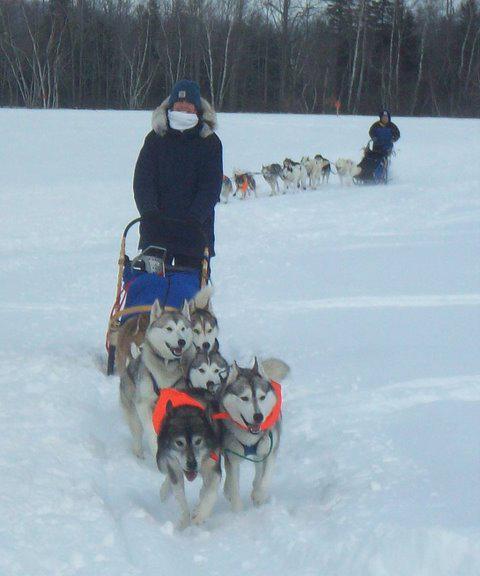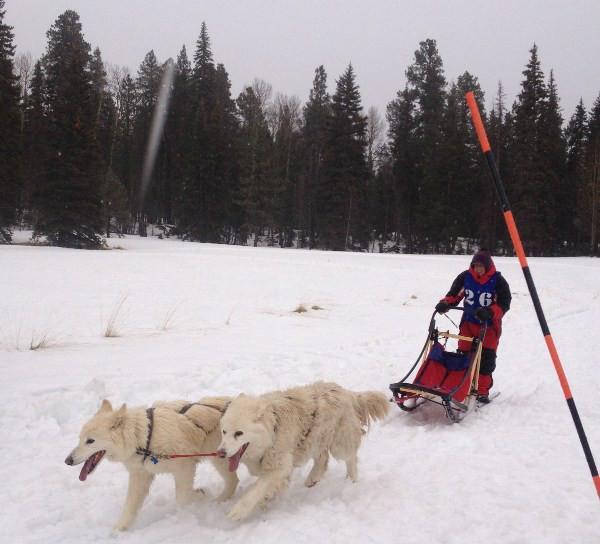The first image is the image on the left, the second image is the image on the right. Given the left and right images, does the statement "The image on the left has a person using a red sled." hold true? Answer yes or no. No. The first image is the image on the left, the second image is the image on the right. For the images displayed, is the sentence "An image shows a sled pulled by two dogs, heading downward and leftward." factually correct? Answer yes or no. Yes. 